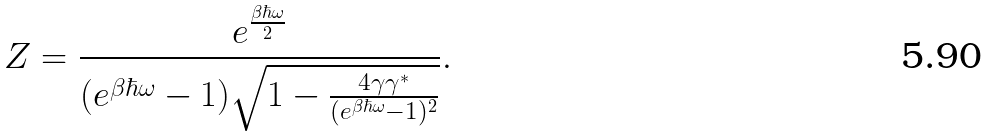Convert formula to latex. <formula><loc_0><loc_0><loc_500><loc_500>Z = \frac { e ^ { \frac { \beta \hbar { \omega } } { 2 } } } { ( e ^ { \beta \hbar { \omega } } - 1 ) \sqrt { 1 - \frac { 4 \gamma \gamma ^ { * } } { ( e ^ { \beta \hbar { \omega } } - 1 ) ^ { 2 } } } } .</formula> 